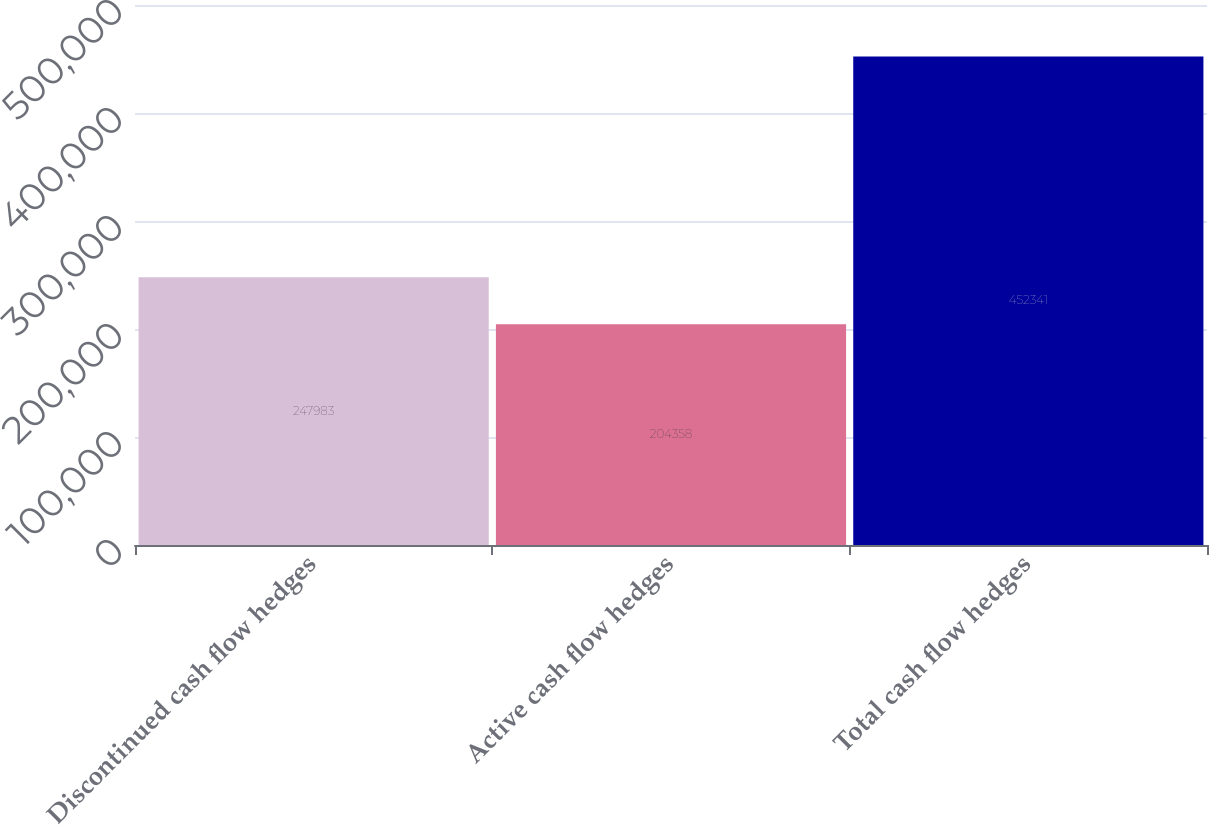Convert chart to OTSL. <chart><loc_0><loc_0><loc_500><loc_500><bar_chart><fcel>Discontinued cash flow hedges<fcel>Active cash flow hedges<fcel>Total cash flow hedges<nl><fcel>247983<fcel>204358<fcel>452341<nl></chart> 